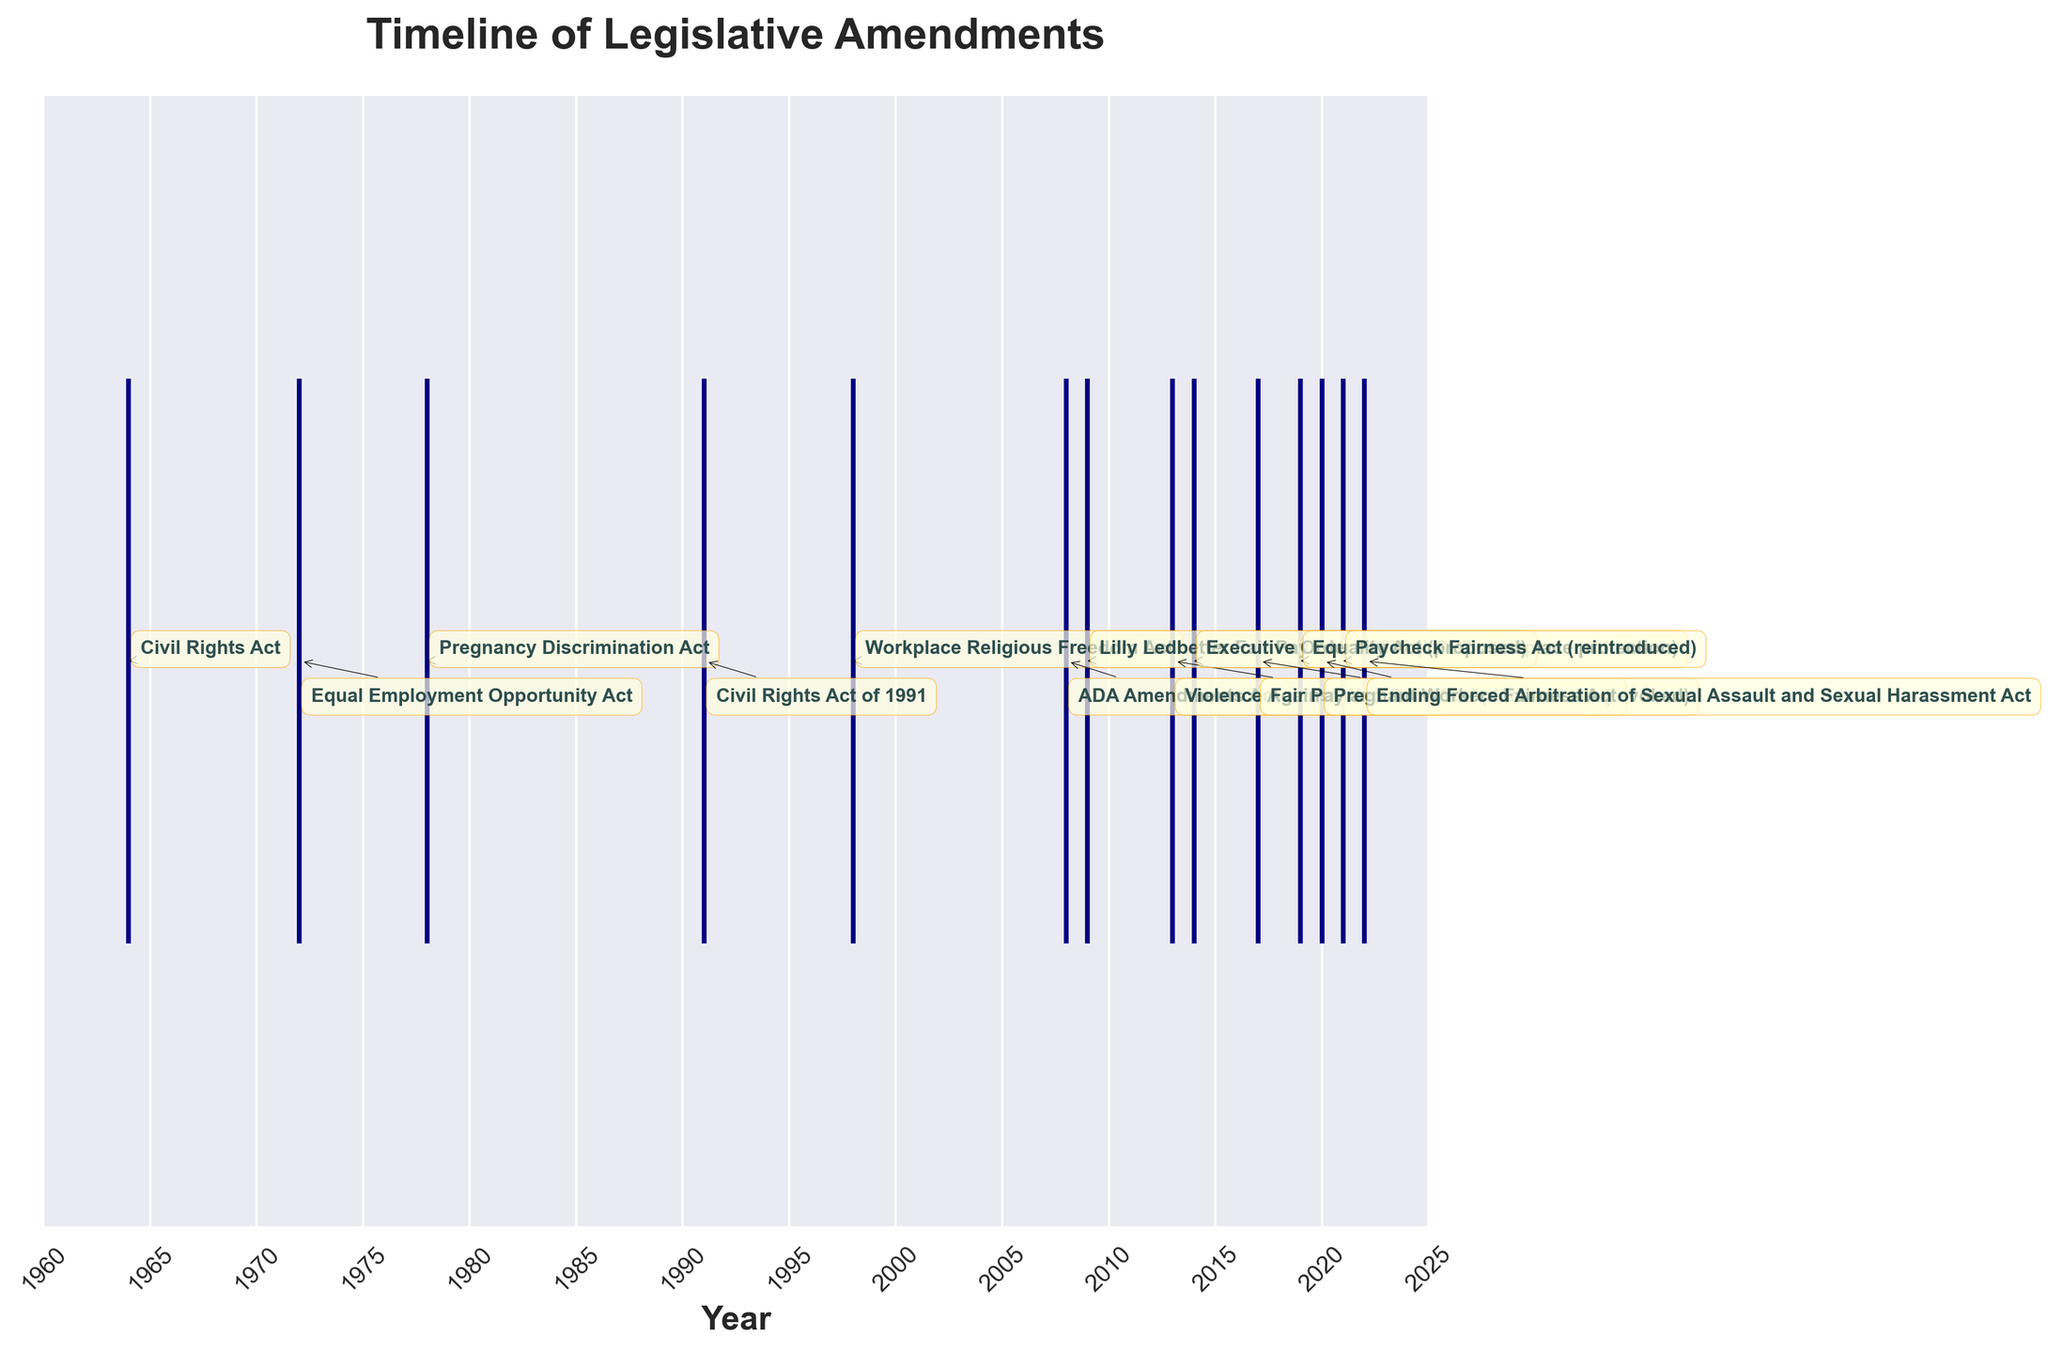What is the title of the plot? The title is generally located at the top of the plot and indicates the subject or purpose of the visual.
Answer: Timeline of Legislative Amendments What is the first amendment shown in the timeline? The first amendment is the earliest one on the x-axis, which is usually on the far left.
Answer: Civil Rights Act How many amendments were made in the year 2000s? Count the number of data points between 2000 and 2009 inclusive.
Answer: 3 Which amendment appears directly after the Pregnancy Discrimination Act of 1978? Find the amendment that corresponds to the year immediately following 1978.
Answer: Civil Rights Act of 1991 What year was the Lilly Ledbetter Fair Pay Act enacted? Look for the year associated with the Lilly Ledbetter Fair Pay Act on the timeline.
Answer: 2009 What is the average interval (in years) between legislative amendments? Calculate the differences between consecutive amendment years, sum these differences, and divide by the number of intervals. For example, differences: 1964-1972, 1972-1978, etc., average these values. The specific calculation would be [(1972-1964) + (1978-1972) + (1991-1978) + (1998-1991) + (2008-1998) + (2009-2008) + (2013-2009) + (2014-2013) + (2017-2014) + (2019-2017) + (2020-2019) + (2021-2020) + (2022-2021)] / 13.
Answer: (8 + 6 + 13 + 7 + 10 + 1 + 4 + 1 + 3 + 2 + 1 + 1 + 1) / 13 = 4.62 years Which amendment was the most recent as of 2022? Identify the amendment associated with the latest year in the timeline.
Answer: Ending Forced Arbitration of Sexual Assault and Sexual Harassment Act Between which years did the most legislative cluster occur? Look for the smallest interval with the highest number of amendments in a given range.
Answer: 2017 to 2022 How many amendments were enacted before the year 2000? Count all amendments that occurred before the year 2000.
Answer: 4 